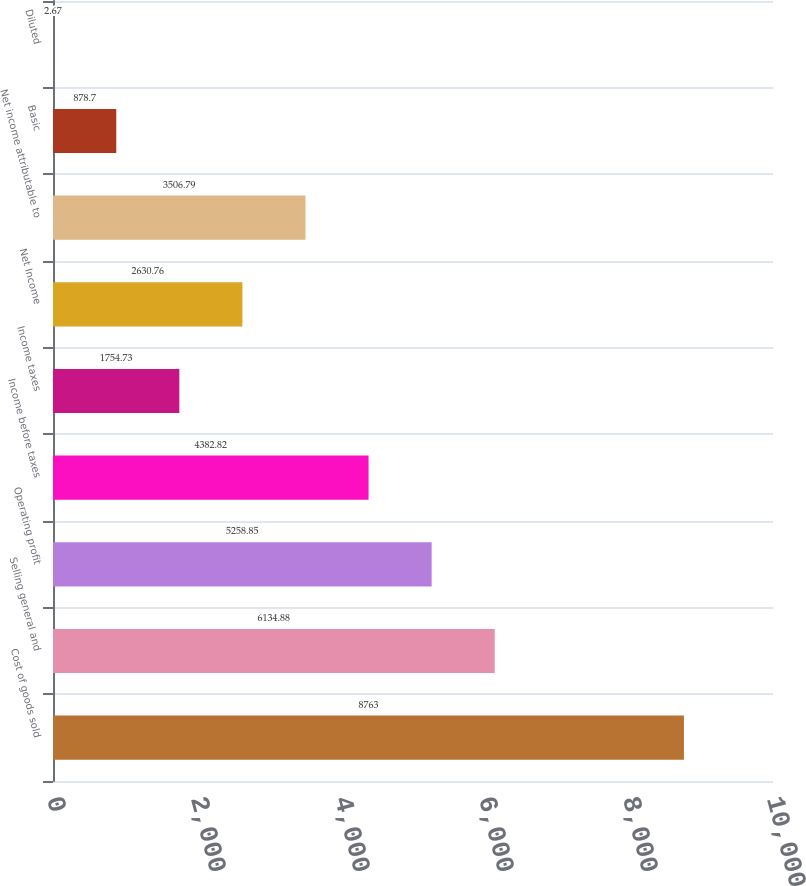Convert chart to OTSL. <chart><loc_0><loc_0><loc_500><loc_500><bar_chart><fcel>Cost of goods sold<fcel>Selling general and<fcel>Operating profit<fcel>Income before taxes<fcel>Income taxes<fcel>Net Income<fcel>Net income attributable to<fcel>Basic<fcel>Diluted<nl><fcel>8763<fcel>6134.88<fcel>5258.85<fcel>4382.82<fcel>1754.73<fcel>2630.76<fcel>3506.79<fcel>878.7<fcel>2.67<nl></chart> 